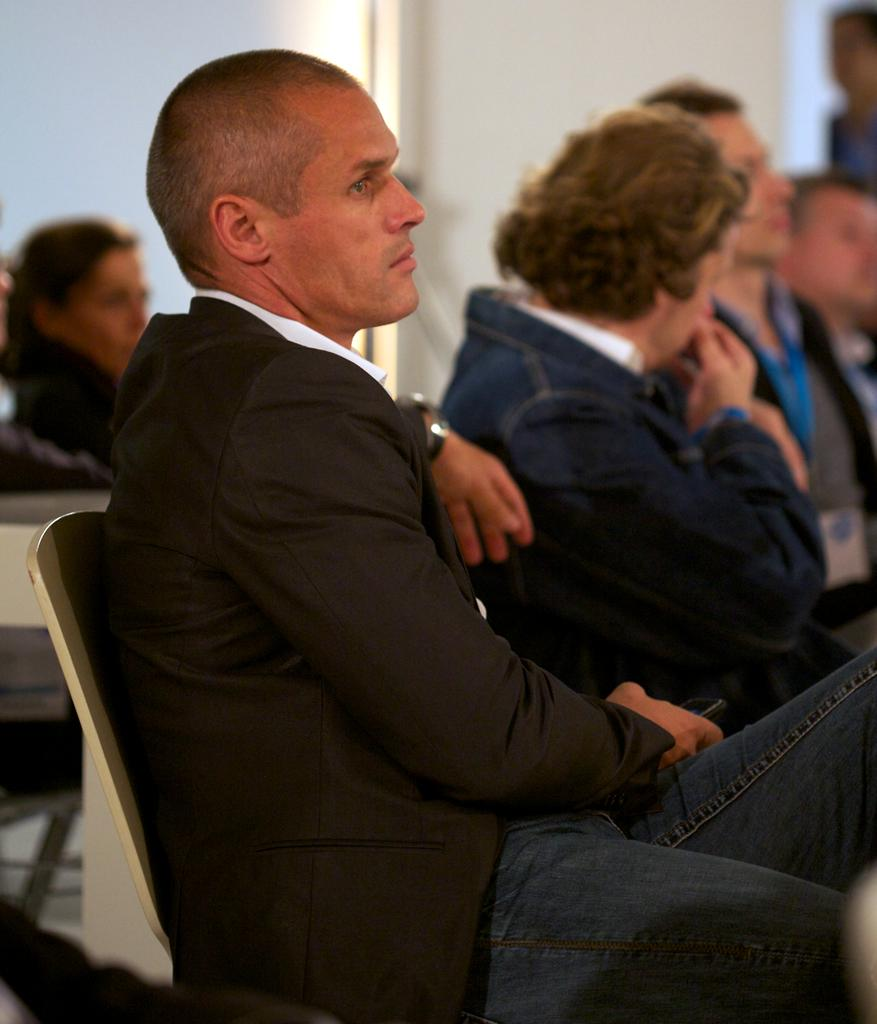What is the person in the image wearing? The person in the image is wearing a black suit. What is the person in the black suit doing? The person in the black suit is sitting on a chair. Are there any other people in the image? Yes, there is a group of people sitting beside the person in the black suit. What health advice is the person in the black suit giving to the group of people? There is no indication in the image that the person in the black suit is giving health advice to the group of people. 